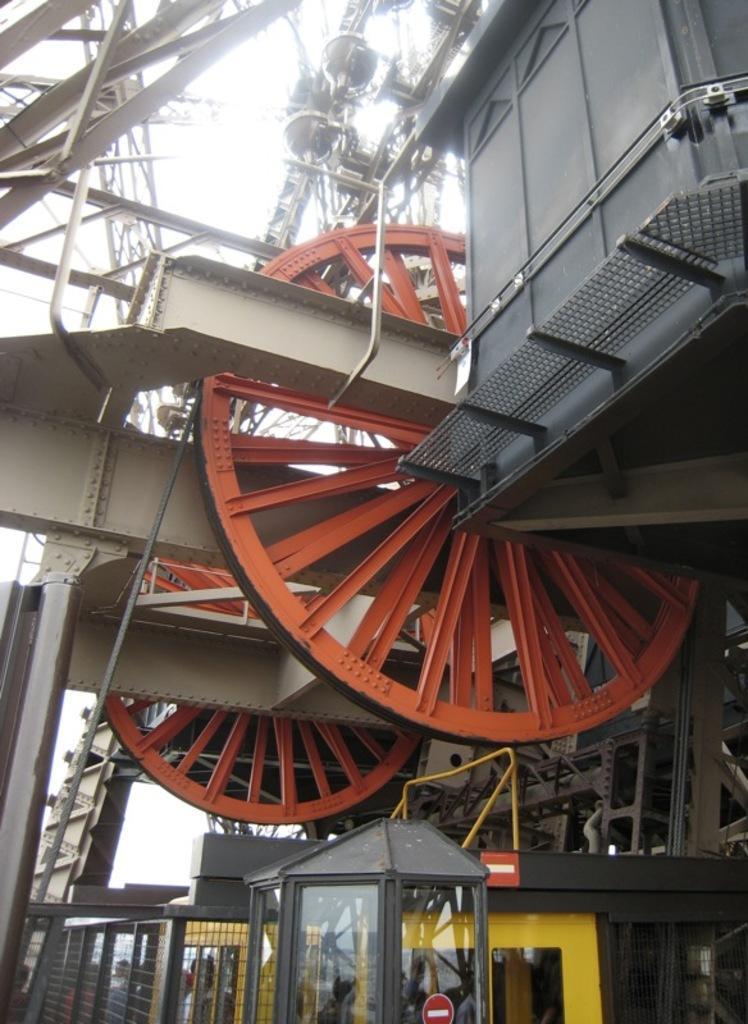Could you give a brief overview of what you see in this image? In this image there are machines, stands and the sky is cloudy and there are persons and there is a grill. 